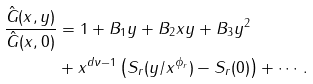<formula> <loc_0><loc_0><loc_500><loc_500>\frac { \hat { G } ( x , y ) } { \hat { G } ( x , 0 ) } & = 1 + B _ { 1 } y + B _ { 2 } x y + B _ { 3 } y ^ { 2 } \\ & + x ^ { d \nu - 1 } \left ( S _ { r } ( y / x ^ { \phi _ { r } } ) - S _ { r } ( 0 ) \right ) + \cdots \, .</formula> 